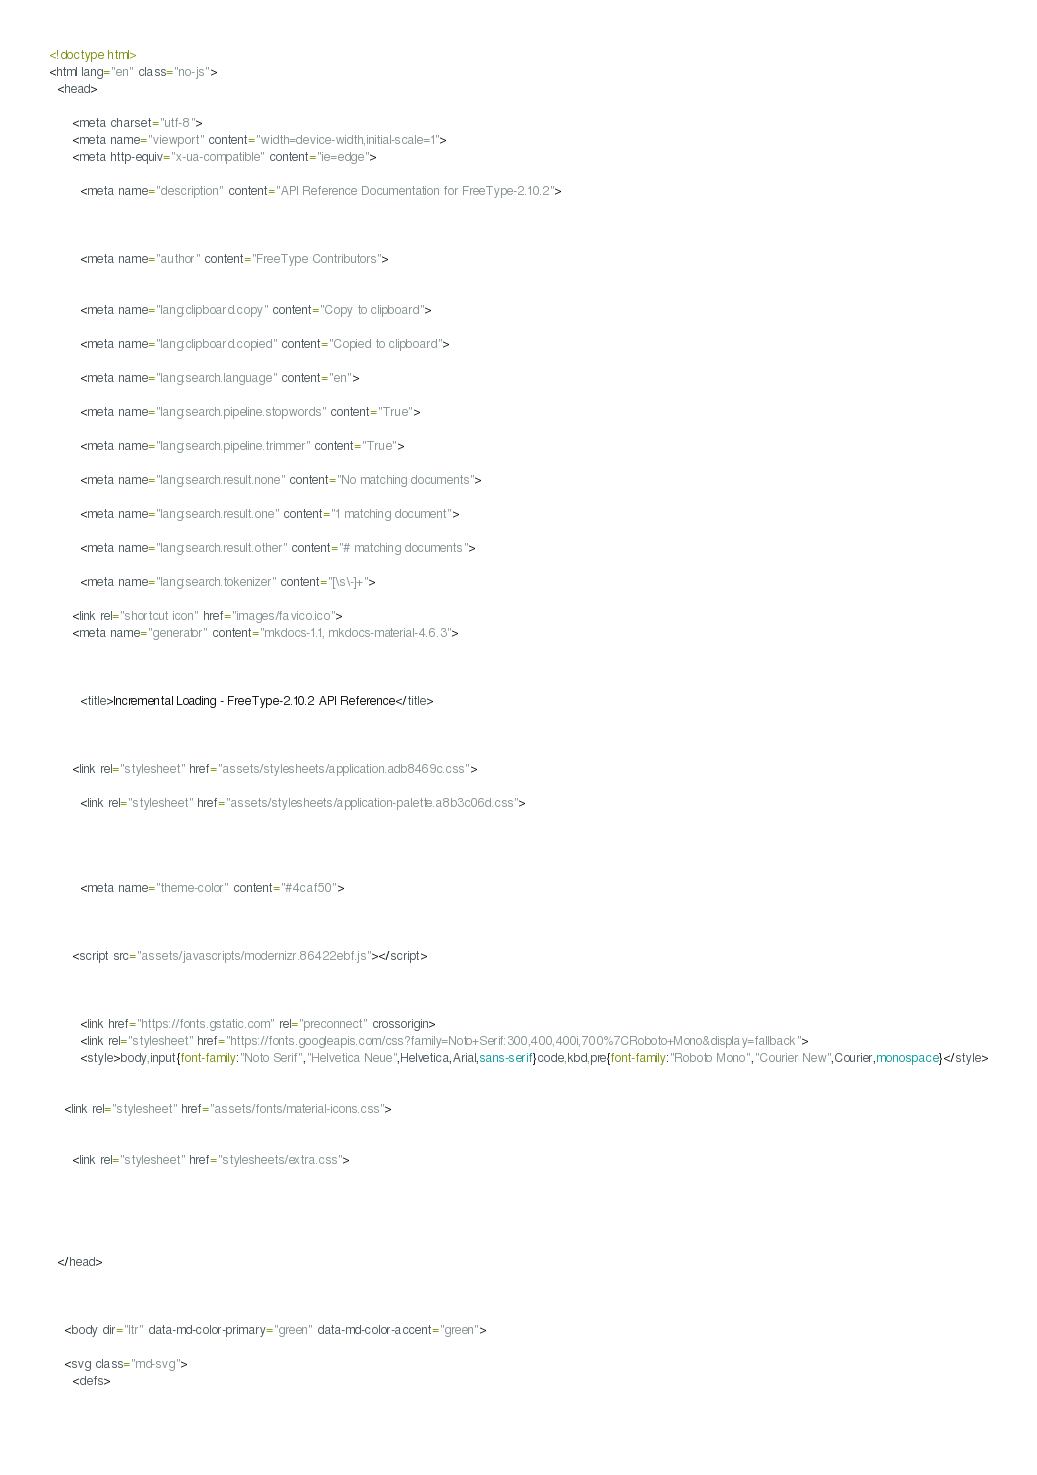Convert code to text. <code><loc_0><loc_0><loc_500><loc_500><_HTML_>



<!doctype html>
<html lang="en" class="no-js">
  <head>
    
      <meta charset="utf-8">
      <meta name="viewport" content="width=device-width,initial-scale=1">
      <meta http-equiv="x-ua-compatible" content="ie=edge">
      
        <meta name="description" content="API Reference Documentation for FreeType-2.10.2">
      
      
      
        <meta name="author" content="FreeType Contributors">
      
      
        <meta name="lang:clipboard.copy" content="Copy to clipboard">
      
        <meta name="lang:clipboard.copied" content="Copied to clipboard">
      
        <meta name="lang:search.language" content="en">
      
        <meta name="lang:search.pipeline.stopwords" content="True">
      
        <meta name="lang:search.pipeline.trimmer" content="True">
      
        <meta name="lang:search.result.none" content="No matching documents">
      
        <meta name="lang:search.result.one" content="1 matching document">
      
        <meta name="lang:search.result.other" content="# matching documents">
      
        <meta name="lang:search.tokenizer" content="[\s\-]+">
      
      <link rel="shortcut icon" href="images/favico.ico">
      <meta name="generator" content="mkdocs-1.1, mkdocs-material-4.6.3">
    
    
      
        <title>Incremental Loading - FreeType-2.10.2 API Reference</title>
      
    
    
      <link rel="stylesheet" href="assets/stylesheets/application.adb8469c.css">
      
        <link rel="stylesheet" href="assets/stylesheets/application-palette.a8b3c06d.css">
      
      
        
        
        <meta name="theme-color" content="#4caf50">
      
    
    
      <script src="assets/javascripts/modernizr.86422ebf.js"></script>
    
    
      
        <link href="https://fonts.gstatic.com" rel="preconnect" crossorigin>
        <link rel="stylesheet" href="https://fonts.googleapis.com/css?family=Noto+Serif:300,400,400i,700%7CRoboto+Mono&display=fallback">
        <style>body,input{font-family:"Noto Serif","Helvetica Neue",Helvetica,Arial,sans-serif}code,kbd,pre{font-family:"Roboto Mono","Courier New",Courier,monospace}</style>
      
    
    <link rel="stylesheet" href="assets/fonts/material-icons.css">
    
    
      <link rel="stylesheet" href="stylesheets/extra.css">
    
    
      
    
    
  </head>
  
    
    
    <body dir="ltr" data-md-color-primary="green" data-md-color-accent="green">
  
    <svg class="md-svg">
      <defs>
        
        </code> 